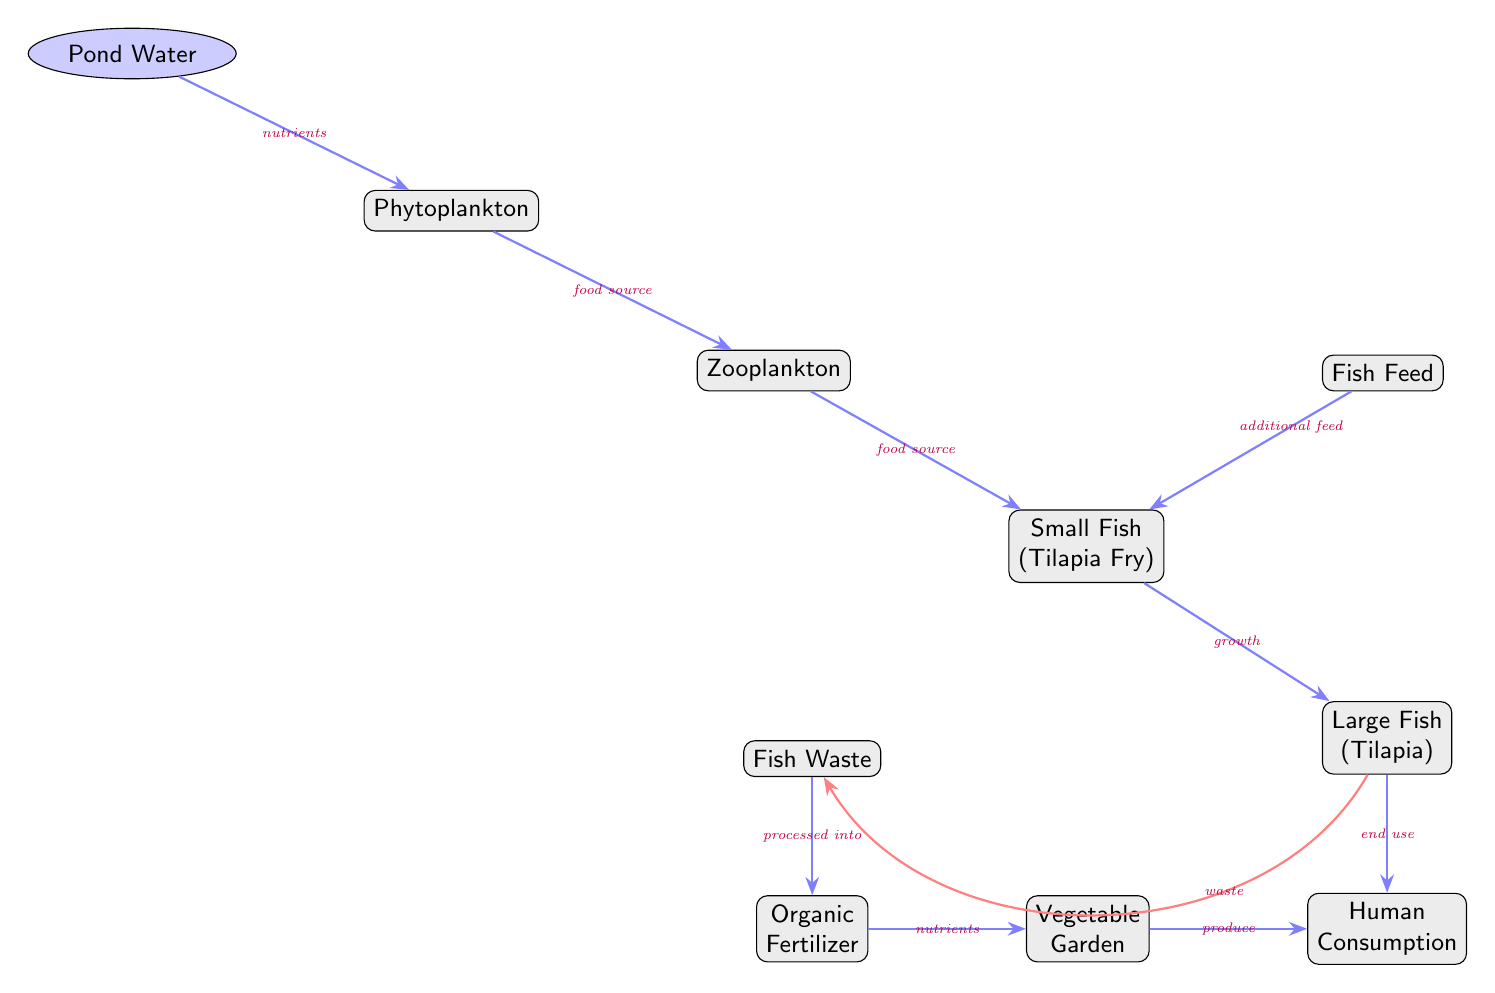What is the first node in the food chain? The first node in the food chain is "Pond Water," which is depicted at the top of the diagram as the starting point of the interaction.
Answer: Pond Water Which node represents the final consumer in the chain? The final consumer in the food chain is represented by "Human Consumption," which is located at the bottom of the diagram, indicating it is the endpoint of the food flow.
Answer: Human Consumption How many food source relationships are shown in the diagram? There are three food source relationships indicated between the nodes: from Phytoplankton to Zooplankton, from Zooplankton to Small Fish, and from Fish Feed to Small Fish.
Answer: Three What type of fertilizer is produced from fish waste? The diagram indicates that "Organic Fertilizer" is produced from "Fish Waste," showing a direct link from the waste to its processed form.
Answer: Organic Fertilizer What role do phytoplankton play in the food chain? Phytoplankton serves as a "food source" for Zooplankton, indicating its role in supporting the dietary needs of the next level in the food chain.
Answer: Food source Which node provides additional feed to small fish? The node that provides additional feed to small fish is "Fish Feed," which enhances their growth and supports the food chain.
Answer: Fish Feed Describe the relationship between large fish and human consumption. The relationship is that large fish are the "end use" in the food chain, meaning they are an important food source for human consumption at the bottom of the feeding hierarchy.
Answer: End use What is processed into fertilizer? "Fish Waste" is processed into "Organic Fertilizer," indicating the cycle of nutrients in the ecosystem that supports vegetable gardening.
Answer: Fish Waste How do nutrients flow from fish waste to vegetable garden? Nutrients flow from "Fish Waste," which is processed into "Organic Fertilizer," and then flows into the "Vegetable Garden," illustrating a nutrient recycling process.
Answer: Nutrients 